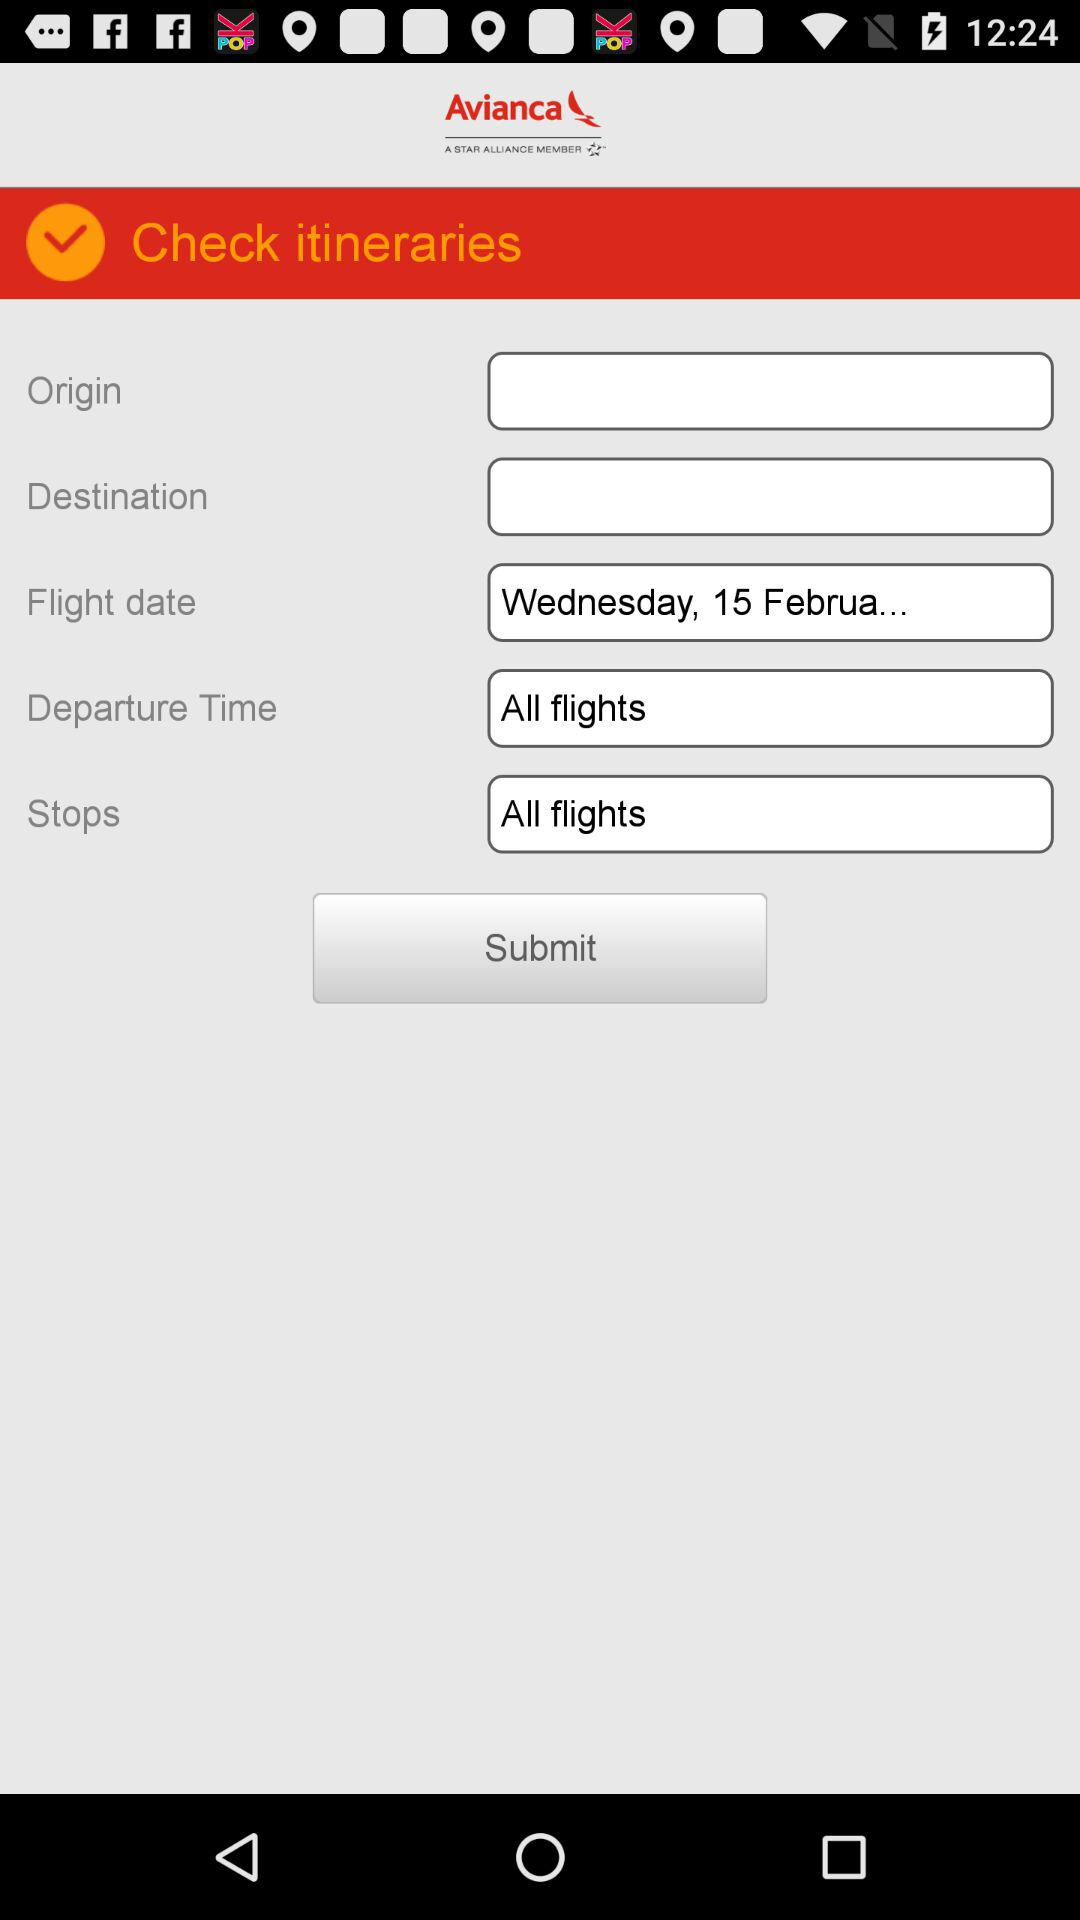What is the flight date? The flight date is "Wednesday, 15 Februa...". 